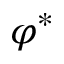<formula> <loc_0><loc_0><loc_500><loc_500>\varphi ^ { * }</formula> 